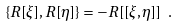<formula> <loc_0><loc_0><loc_500><loc_500>\{ R [ \xi ] , R [ \eta ] \} = - R [ [ \xi , \eta ] ] \ .</formula> 